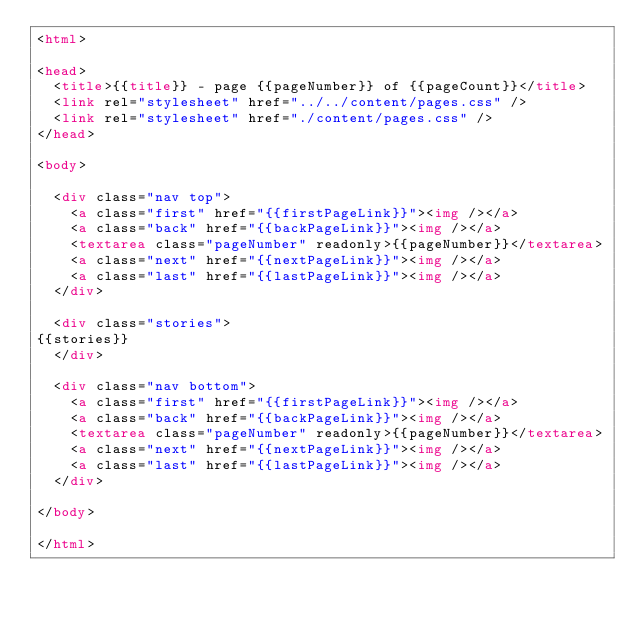Convert code to text. <code><loc_0><loc_0><loc_500><loc_500><_HTML_><html>

<head>
	<title>{{title}} - page {{pageNumber}} of {{pageCount}}</title>
	<link rel="stylesheet" href="../../content/pages.css" />
	<link rel="stylesheet" href="./content/pages.css" />
</head>

<body>

	<div class="nav top">
		<a class="first" href="{{firstPageLink}}"><img /></a>
		<a class="back" href="{{backPageLink}}"><img /></a>
		<textarea class="pageNumber" readonly>{{pageNumber}}</textarea>
		<a class="next" href="{{nextPageLink}}"><img /></a>
		<a class="last" href="{{lastPageLink}}"><img /></a>
	</div>

	<div class="stories">
{{stories}}
	</div>

	<div class="nav bottom">
		<a class="first" href="{{firstPageLink}}"><img /></a>
		<a class="back" href="{{backPageLink}}"><img /></a>
		<textarea class="pageNumber" readonly>{{pageNumber}}</textarea>
		<a class="next" href="{{nextPageLink}}"><img /></a>
		<a class="last" href="{{lastPageLink}}"><img /></a>
	</div>

</body>

</html>
</code> 